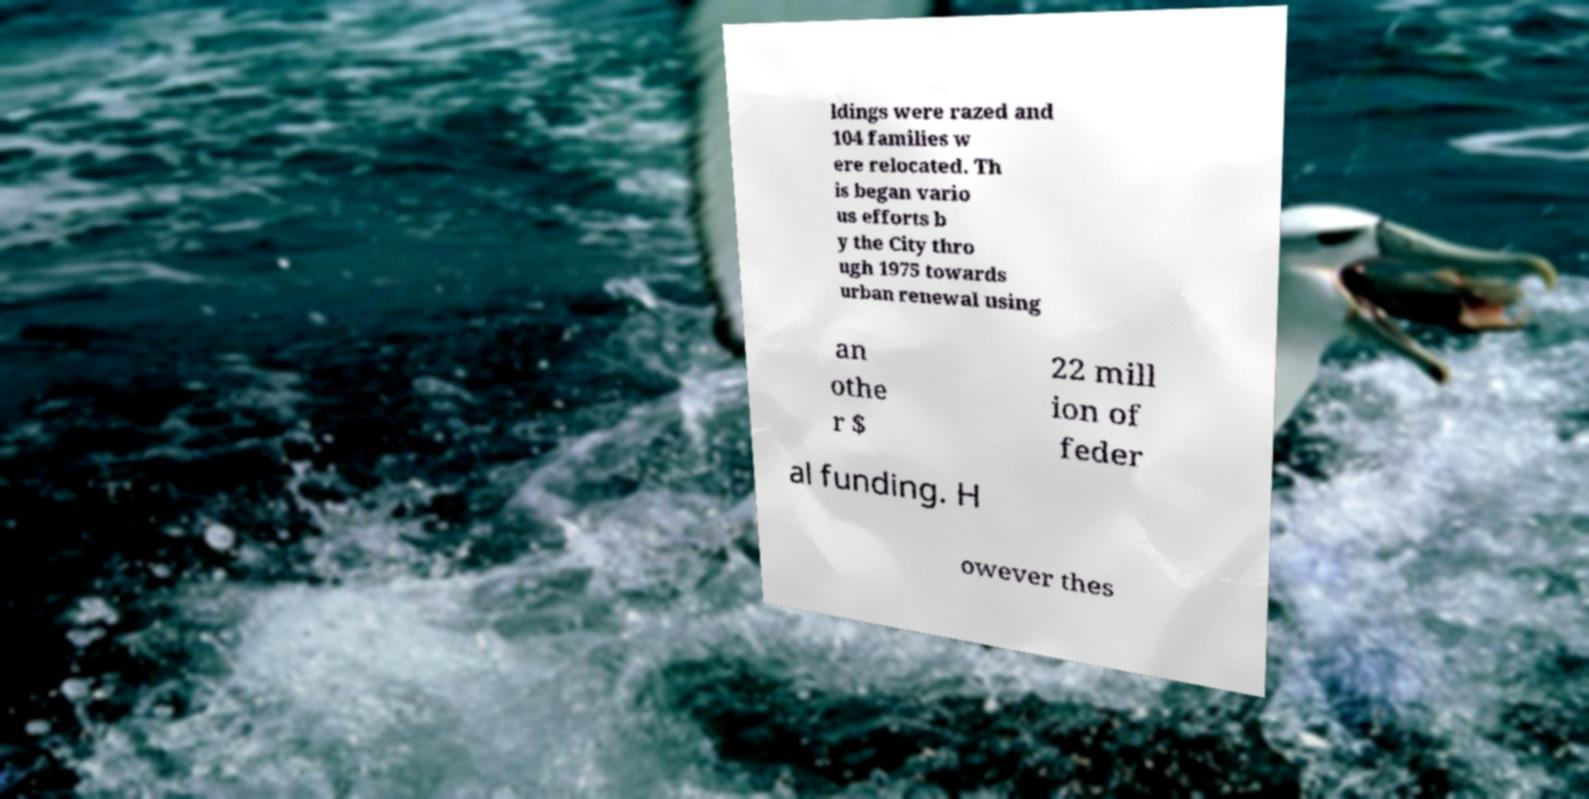Can you accurately transcribe the text from the provided image for me? ldings were razed and 104 families w ere relocated. Th is began vario us efforts b y the City thro ugh 1975 towards urban renewal using an othe r $ 22 mill ion of feder al funding. H owever thes 